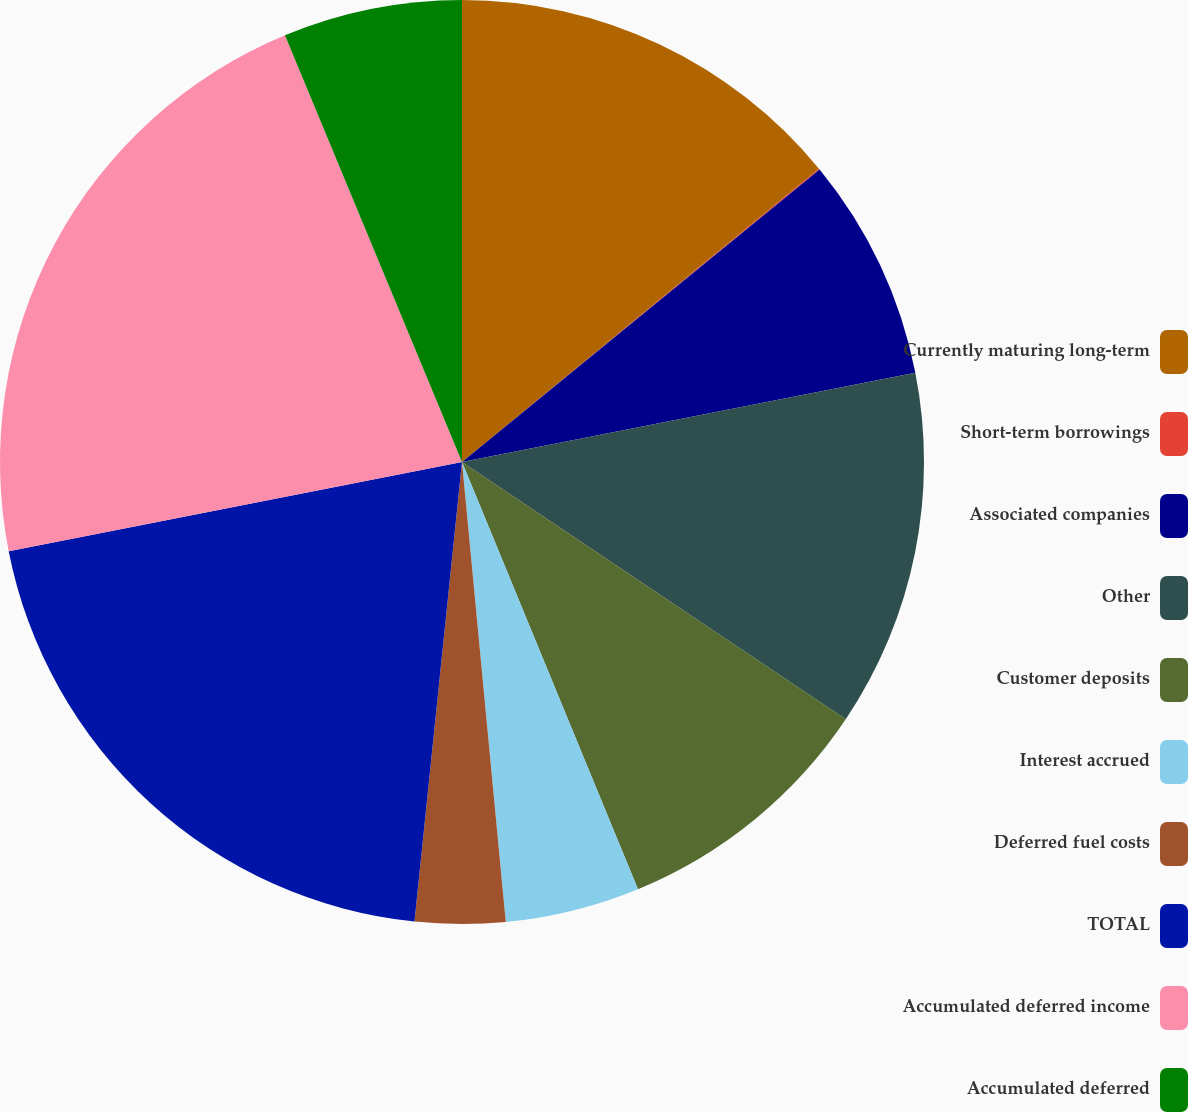Convert chart. <chart><loc_0><loc_0><loc_500><loc_500><pie_chart><fcel>Currently maturing long-term<fcel>Short-term borrowings<fcel>Associated companies<fcel>Other<fcel>Customer deposits<fcel>Interest accrued<fcel>Deferred fuel costs<fcel>TOTAL<fcel>Accumulated deferred income<fcel>Accumulated deferred<nl><fcel>14.05%<fcel>0.04%<fcel>7.82%<fcel>12.49%<fcel>9.38%<fcel>4.71%<fcel>3.15%<fcel>20.27%<fcel>21.83%<fcel>6.26%<nl></chart> 